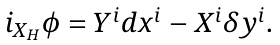<formula> <loc_0><loc_0><loc_500><loc_500>\begin{array} { l } i _ { X _ { H } } \phi = Y ^ { i } d x ^ { i } - X ^ { i } \delta y ^ { i } . \end{array}</formula> 